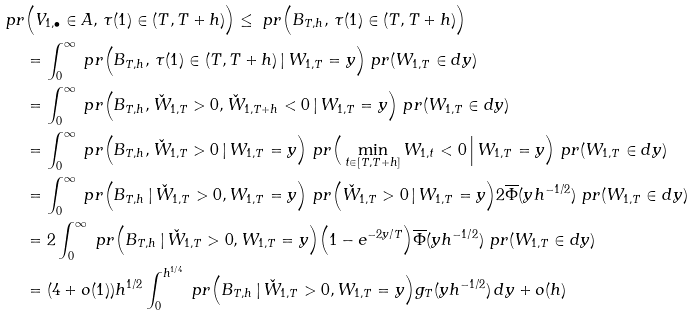<formula> <loc_0><loc_0><loc_500><loc_500>\ p r & \Big ( V _ { 1 , \bullet } \in A , \, \tau ( 1 ) \in ( T , T + h ) \Big ) \leq \ p r \Big ( B _ { T , h } , \, \tau ( 1 ) \in ( T , T + h ) \Big ) \\ & = \int _ { 0 } ^ { \infty } \ p r \Big ( B _ { T , h } , \, \tau ( 1 ) \in ( T , T + h ) \, | \, W _ { 1 , T } = y \Big ) \ p r ( W _ { 1 , T } \in d y ) \\ & = \int _ { 0 } ^ { \infty } \ p r \Big ( B _ { T , h } , \check { W } _ { 1 , T } > 0 , \check { W } _ { 1 , T + h } < 0 \, | \, W _ { 1 , T } = y \Big ) \ p r ( W _ { 1 , T } \in d y ) \\ & = \int _ { 0 } ^ { \infty } \ p r \Big ( B _ { T , h } , \check { W } _ { 1 , T } > 0 \, | \, W _ { 1 , T } = y \Big ) \ p r \Big ( \min _ { t \in [ T , T + h ] } W _ { 1 , t } < 0 \, \Big | \, W _ { 1 , T } = y \Big ) \ p r ( W _ { 1 , T } \in d y ) \\ & = \int _ { 0 } ^ { \infty } \ p r \Big ( B _ { T , h } \, | \, \check { W } _ { 1 , T } > 0 , W _ { 1 , T } = y \Big ) \ p r \Big ( \check { W } _ { 1 , T } > 0 \, | \, W _ { 1 , T } = y \Big ) 2 \overline { \Phi } ( y h ^ { - 1 / 2 } ) \ p r ( W _ { 1 , T } \in d y ) \\ & = 2 \int _ { 0 } ^ { \infty } \ p r \Big ( B _ { T , h } \, | \, \check { W } _ { 1 , T } > 0 , W _ { 1 , T } = y \Big ) \Big ( 1 - e ^ { - 2 y / T } \Big ) \overline { \Phi } ( y h ^ { - 1 / 2 } ) \ p r ( W _ { 1 , T } \in d y ) \\ & = ( 4 + o ( 1 ) ) h ^ { 1 / 2 } \int _ { 0 } ^ { h ^ { 1 / 4 } } \ p r \Big ( B _ { T , h } \, | \, \check { W } _ { 1 , T } > 0 , W _ { 1 , T } = y \Big ) g _ { T } ( y h ^ { - 1 / 2 } ) \, d y + o ( h )</formula> 